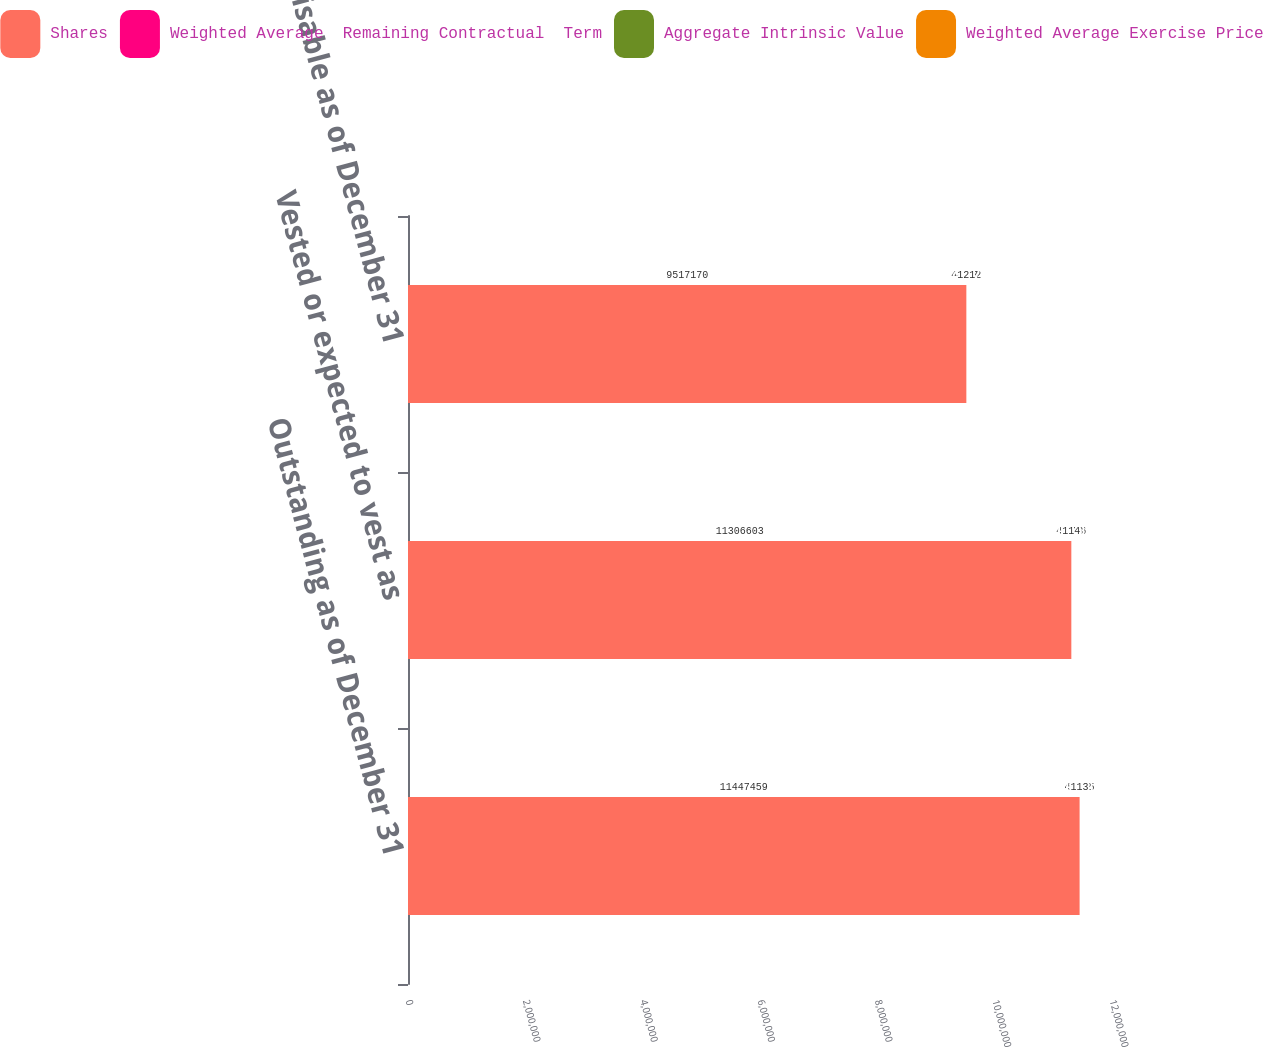<chart> <loc_0><loc_0><loc_500><loc_500><stacked_bar_chart><ecel><fcel>Outstanding as of December 31<fcel>Vested or expected to vest as<fcel>Exercisable as of December 31<nl><fcel>Shares<fcel>1.14475e+07<fcel>1.13066e+07<fcel>9.51717e+06<nl><fcel>Weighted Average  Remaining Contractual  Term<fcel>48.35<fcel>48.16<fcel>45.52<nl><fcel>Aggregate Intrinsic Value<fcel>5.22<fcel>5.18<fcel>4.57<nl><fcel>Weighted Average Exercise Price<fcel>113<fcel>114<fcel>121<nl></chart> 